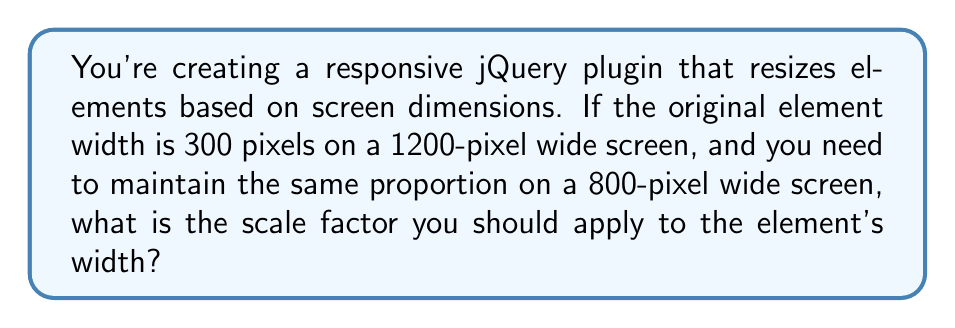Solve this math problem. To solve this problem, we need to understand the concept of proportional scaling. The scale factor is the ratio between the new size and the original size.

Let's break it down step by step:

1. Define the known values:
   - Original screen width: $w_1 = 1200$ pixels
   - New screen width: $w_2 = 800$ pixels
   - Original element width: $e_1 = 300$ pixels

2. We need to find the new element width $e_2$ that maintains the same proportion. We can set up a proportion:

   $$\frac{e_1}{w_1} = \frac{e_2}{w_2}$$

3. Cross multiply:

   $$e_1 \cdot w_2 = e_2 \cdot w_1$$

4. Solve for $e_2$:

   $$e_2 = \frac{e_1 \cdot w_2}{w_1}$$

5. Plug in the known values:

   $$e_2 = \frac{300 \cdot 800}{1200} = 200$$

6. The scale factor is the ratio of the new size to the original size:

   $$\text{scale factor} = \frac{e_2}{e_1} = \frac{200}{300} = \frac{2}{3}$$

This scale factor can be used in jQuery to resize the element using methods like `.css('transform', 'scale(' + scaleFactor + ')')` or by directly setting the width.
Answer: $\frac{2}{3}$ or approximately $0.6667$ 